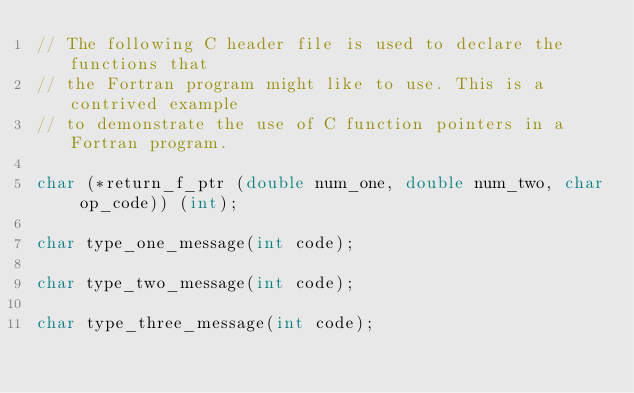Convert code to text. <code><loc_0><loc_0><loc_500><loc_500><_C_>// The following C header file is used to declare the functions that
// the Fortran program might like to use. This is a contrived example
// to demonstrate the use of C function pointers in a Fortran program.

char (*return_f_ptr (double num_one, double num_two, char op_code)) (int);

char type_one_message(int code);

char type_two_message(int code);

char type_three_message(int code);
</code> 